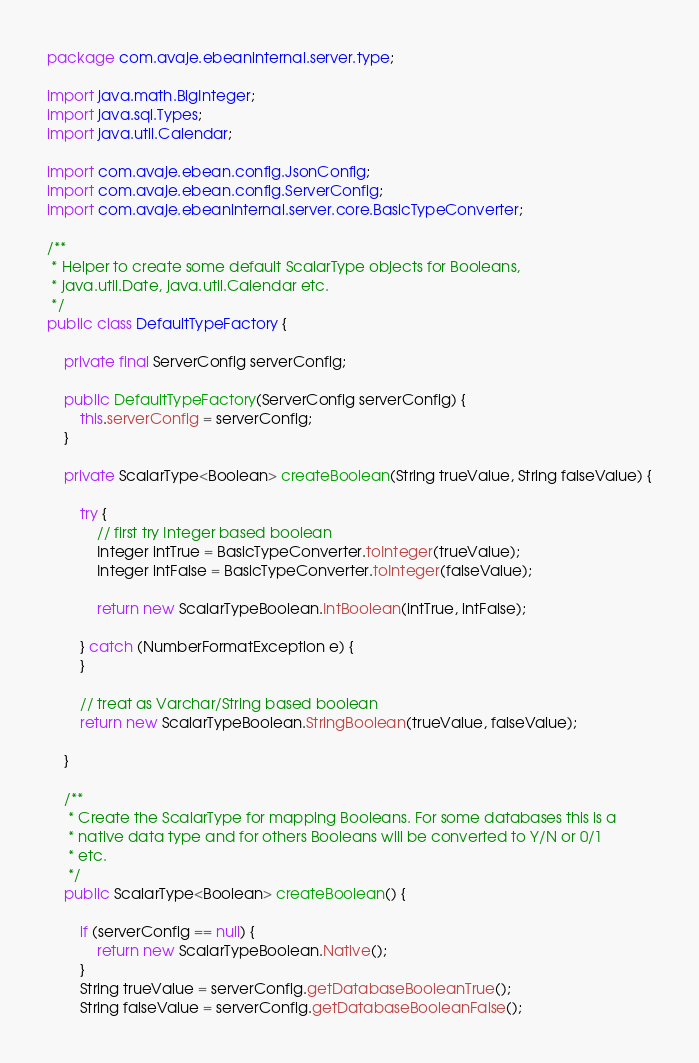Convert code to text. <code><loc_0><loc_0><loc_500><loc_500><_Java_>package com.avaje.ebeaninternal.server.type;

import java.math.BigInteger;
import java.sql.Types;
import java.util.Calendar;

import com.avaje.ebean.config.JsonConfig;
import com.avaje.ebean.config.ServerConfig;
import com.avaje.ebeaninternal.server.core.BasicTypeConverter;

/**
 * Helper to create some default ScalarType objects for Booleans,
 * java.util.Date, java.util.Calendar etc.
 */
public class DefaultTypeFactory {

    private final ServerConfig serverConfig;

    public DefaultTypeFactory(ServerConfig serverConfig) {
        this.serverConfig = serverConfig;
    }

    private ScalarType<Boolean> createBoolean(String trueValue, String falseValue) {

        try {
            // first try Integer based boolean
            Integer intTrue = BasicTypeConverter.toInteger(trueValue);
            Integer intFalse = BasicTypeConverter.toInteger(falseValue);

            return new ScalarTypeBoolean.IntBoolean(intTrue, intFalse);

        } catch (NumberFormatException e) {
        }

        // treat as Varchar/String based boolean
        return new ScalarTypeBoolean.StringBoolean(trueValue, falseValue);

    }

    /**
     * Create the ScalarType for mapping Booleans. For some databases this is a
     * native data type and for others Booleans will be converted to Y/N or 0/1
     * etc.
     */
    public ScalarType<Boolean> createBoolean() {

        if (serverConfig == null) {
            return new ScalarTypeBoolean.Native();
        }
        String trueValue = serverConfig.getDatabaseBooleanTrue();
        String falseValue = serverConfig.getDatabaseBooleanFalse();
</code> 